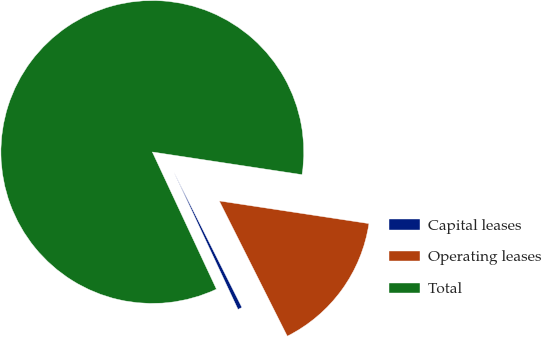Convert chart to OTSL. <chart><loc_0><loc_0><loc_500><loc_500><pie_chart><fcel>Capital leases<fcel>Operating leases<fcel>Total<nl><fcel>0.46%<fcel>15.19%<fcel>84.35%<nl></chart> 